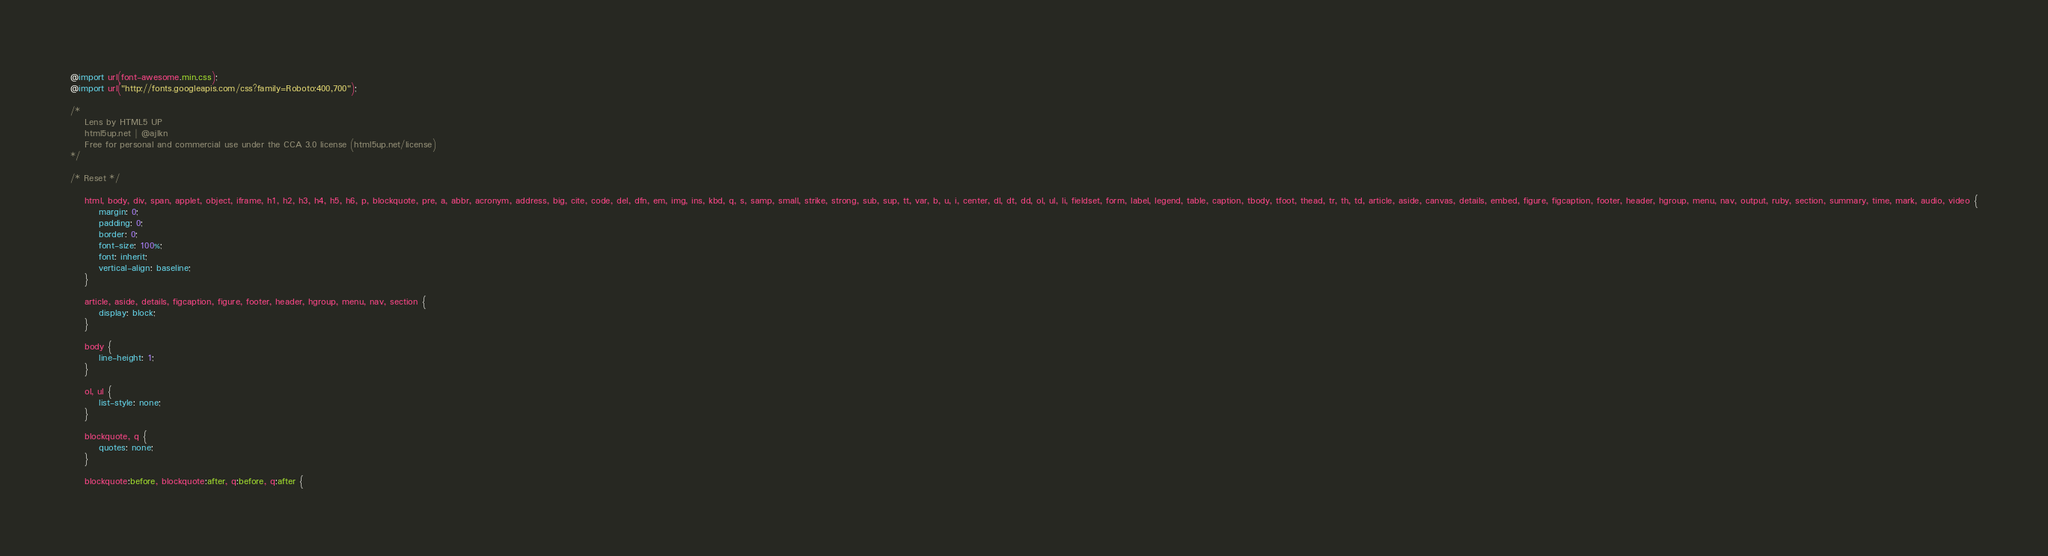Convert code to text. <code><loc_0><loc_0><loc_500><loc_500><_CSS_>@import url(font-awesome.min.css);
@import url("http://fonts.googleapis.com/css?family=Roboto:400,700");

/*
	Lens by HTML5 UP
	html5up.net | @ajlkn
	Free for personal and commercial use under the CCA 3.0 license (html5up.net/license)
*/

/* Reset */

	html, body, div, span, applet, object, iframe, h1, h2, h3, h4, h5, h6, p, blockquote, pre, a, abbr, acronym, address, big, cite, code, del, dfn, em, img, ins, kbd, q, s, samp, small, strike, strong, sub, sup, tt, var, b, u, i, center, dl, dt, dd, ol, ul, li, fieldset, form, label, legend, table, caption, tbody, tfoot, thead, tr, th, td, article, aside, canvas, details, embed, figure, figcaption, footer, header, hgroup, menu, nav, output, ruby, section, summary, time, mark, audio, video {
		margin: 0;
		padding: 0;
		border: 0;
		font-size: 100%;
		font: inherit;
		vertical-align: baseline;
	}

	article, aside, details, figcaption, figure, footer, header, hgroup, menu, nav, section {
		display: block;
	}

	body {
		line-height: 1;
	}

	ol, ul {
		list-style: none;
	}

	blockquote, q {
		quotes: none;
	}

	blockquote:before, blockquote:after, q:before, q:after {</code> 